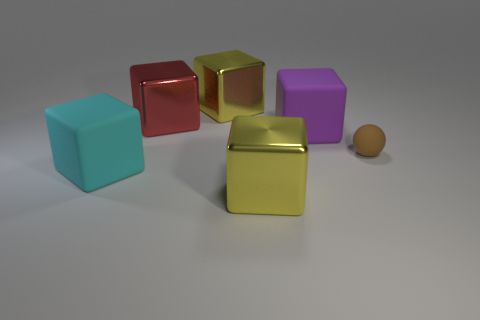There is a yellow object that is in front of the cyan cube; what is its shape?
Keep it short and to the point. Cube. There is a large yellow metal cube behind the purple object; is there a large yellow block right of it?
Make the answer very short. Yes. There is a matte object that is on the right side of the big red object and left of the brown sphere; what color is it?
Your response must be concise. Purple. Is there a tiny rubber sphere that is to the right of the matte block left of the yellow metal object that is in front of the large cyan rubber block?
Keep it short and to the point. Yes. What is the size of the purple matte thing that is the same shape as the big cyan rubber thing?
Make the answer very short. Large. Are any large red metal objects visible?
Provide a succinct answer. Yes. There is a yellow block in front of the block right of the shiny object that is in front of the large cyan rubber cube; what is its size?
Offer a very short reply. Large. How many other metallic objects have the same color as the small thing?
Offer a terse response. 0. How many things are either large cyan cubes or big metal blocks that are behind the purple matte object?
Your answer should be compact. 3. The rubber sphere has what color?
Provide a short and direct response. Brown. 